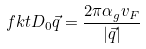Convert formula to latex. <formula><loc_0><loc_0><loc_500><loc_500>\ f k t { D _ { 0 } } { \vec { q } } = \frac { 2 \pi \alpha _ { g } v _ { F } } { | \vec { q } | }</formula> 